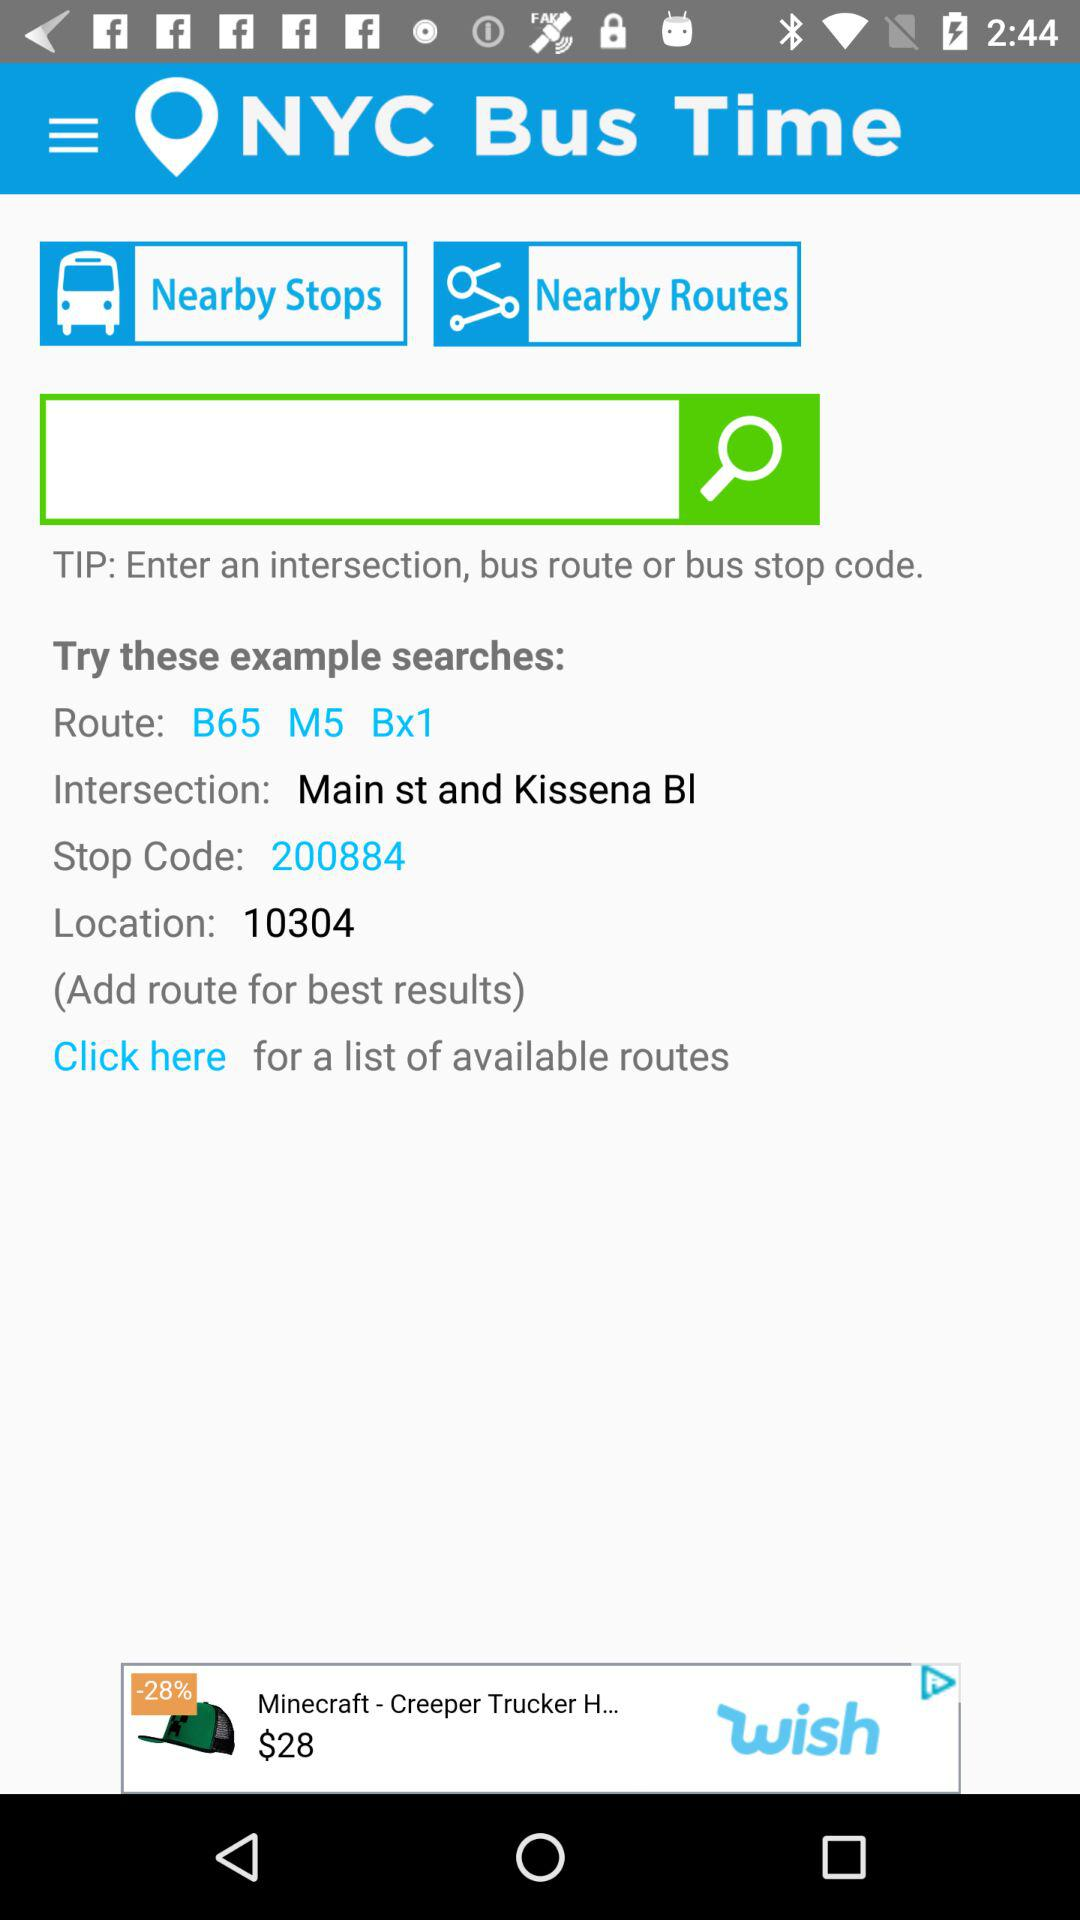What is the number in "Location"? The number in "Location" is 10304. 